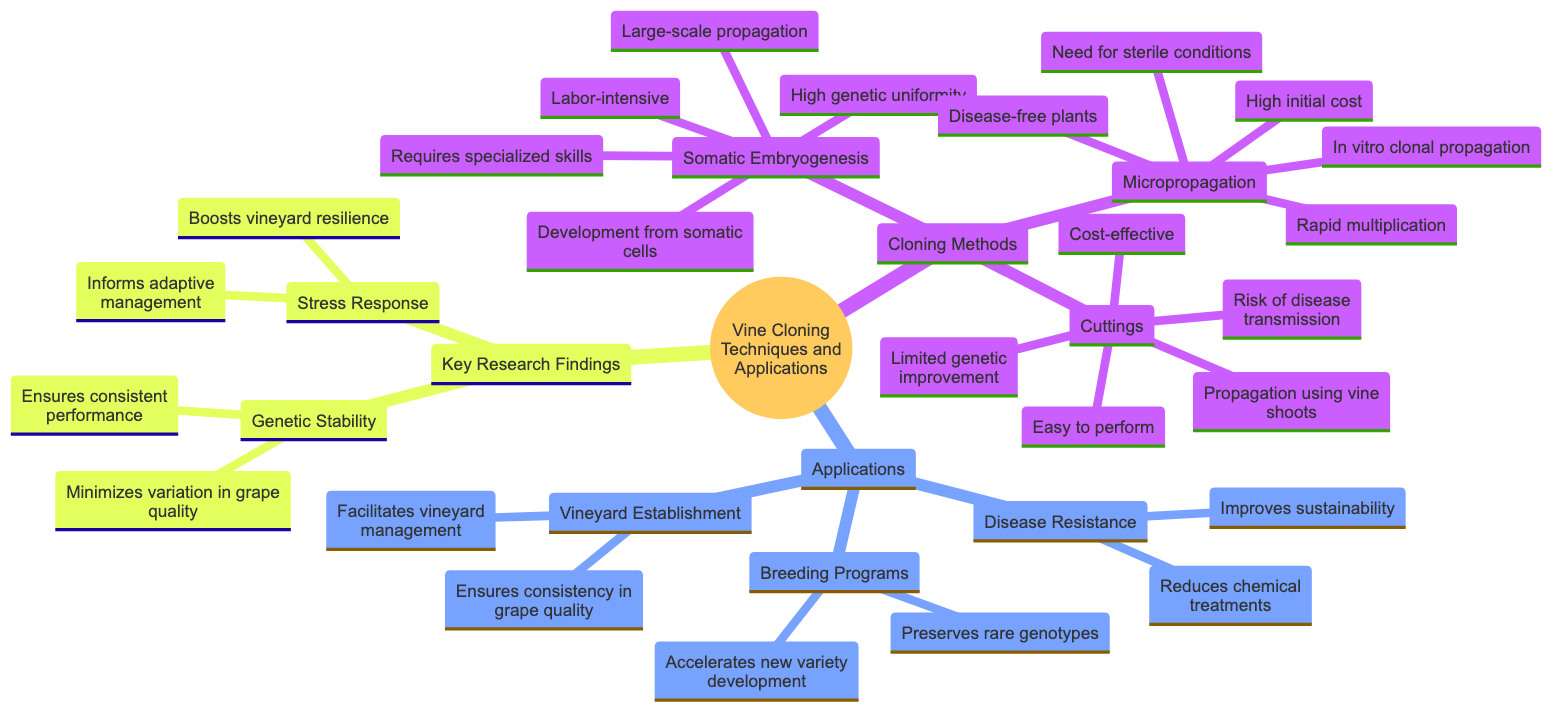What are the three main cloning methods listed? The diagram presents three primary methods of cloning: Somatic Embryogenesis, Cuttings, and Micropropagation. Each method is an individual node under the "Cloning Methods" category.
Answer: Somatic Embryogenesis, Cuttings, Micropropagation What benefit does micropropagation provide? Micropropagation offers several benefits, one of which is "Disease-free plants." This is indicated directly under the Micropropagation node in the benefits list.
Answer: Disease-free plants What is a challenge of somatic embryogenesis? The diagram lists "Labor-intensive" as one of the challenges of somatic embryogenesis. This information can be found under the respective challenges section of the Somatic Embryogenesis node.
Answer: Labor-intensive How does vineyard establishment benefit from cloning techniques? The benefit of vineyard establishment from cloning techniques includes "Ensures consistency in grape quality," which is explained under the Vineyard Establishment node.
Answer: Ensures consistency in grape quality What impact does genetic stability have on grape quality? The impact of genetic stability is twofold, but one specific impact listed is "Minimizes variation in grape quality." This is found under the "Genetic Stability" node in the Key Research Findings section.
Answer: Minimizes variation in grape quality What cloning method is described as cost-effective? Cuttings are described as "Cost-effective," as noted in the benefits section for the Cuttings node.
Answer: Cost-effective How many applications of vine cloning techniques are mentioned in the diagram? The diagram presents three applications of vine cloning techniques, which are Vineyard Establishment, Breeding Programs, and Disease Resistance. This can be counted as distinct nodes under the Applications category.
Answer: 3 What is one of the benefits of breeding programs using cloning techniques? One of the benefits noted under Breeding Programs is "Accelerates development of new varieties," which specifically highlights the advantages of incorporating cloning in breeding efforts.
Answer: Accelerates development of new varieties Describe the role of stress response research in vineyard management. The impact of stress response findings is that it "Informs adaptive management practices," thus indicating how research in stress response could be utilized to improve vineyard management.
Answer: Informs adaptive management practices 